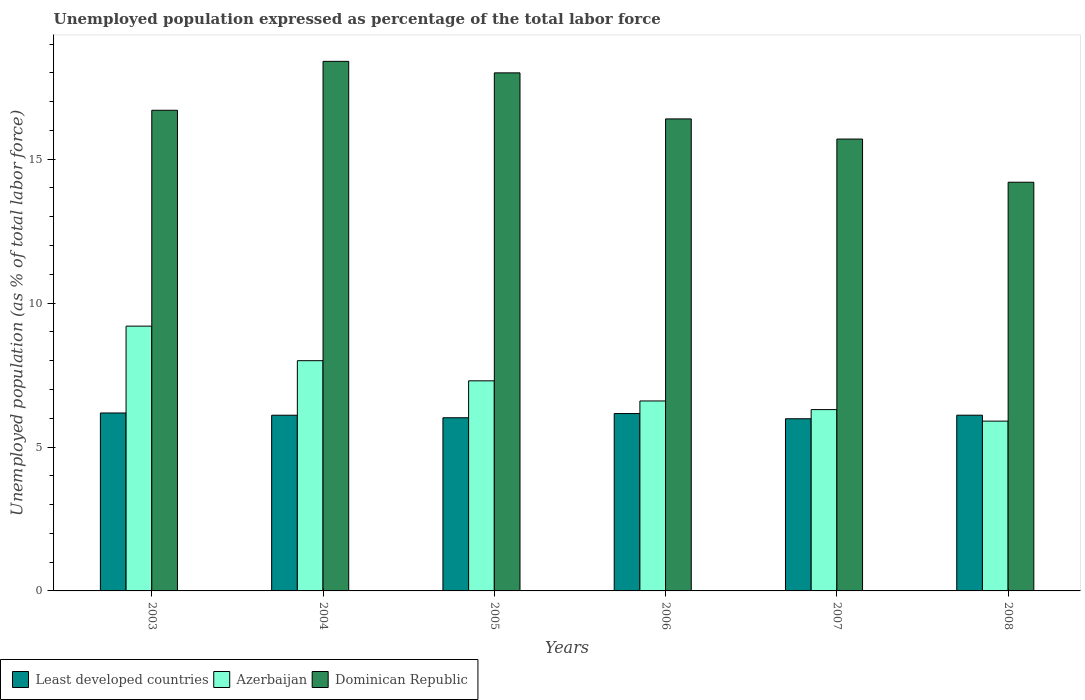How many groups of bars are there?
Your answer should be very brief. 6. Are the number of bars per tick equal to the number of legend labels?
Your answer should be compact. Yes. What is the label of the 1st group of bars from the left?
Your answer should be compact. 2003. In how many cases, is the number of bars for a given year not equal to the number of legend labels?
Offer a terse response. 0. Across all years, what is the maximum unemployment in in Dominican Republic?
Your answer should be very brief. 18.4. Across all years, what is the minimum unemployment in in Least developed countries?
Offer a very short reply. 5.98. In which year was the unemployment in in Azerbaijan minimum?
Your answer should be compact. 2008. What is the total unemployment in in Dominican Republic in the graph?
Ensure brevity in your answer.  99.4. What is the difference between the unemployment in in Azerbaijan in 2003 and that in 2004?
Offer a very short reply. 1.2. What is the difference between the unemployment in in Dominican Republic in 2008 and the unemployment in in Azerbaijan in 2003?
Keep it short and to the point. 5. What is the average unemployment in in Azerbaijan per year?
Keep it short and to the point. 7.22. In the year 2003, what is the difference between the unemployment in in Dominican Republic and unemployment in in Least developed countries?
Keep it short and to the point. 10.52. What is the ratio of the unemployment in in Least developed countries in 2005 to that in 2008?
Provide a short and direct response. 0.99. Is the unemployment in in Azerbaijan in 2007 less than that in 2008?
Offer a terse response. No. What is the difference between the highest and the second highest unemployment in in Least developed countries?
Keep it short and to the point. 0.02. What is the difference between the highest and the lowest unemployment in in Azerbaijan?
Offer a terse response. 3.3. Is the sum of the unemployment in in Least developed countries in 2004 and 2008 greater than the maximum unemployment in in Dominican Republic across all years?
Your answer should be very brief. No. What does the 3rd bar from the left in 2005 represents?
Your answer should be compact. Dominican Republic. What does the 3rd bar from the right in 2005 represents?
Give a very brief answer. Least developed countries. Is it the case that in every year, the sum of the unemployment in in Azerbaijan and unemployment in in Dominican Republic is greater than the unemployment in in Least developed countries?
Make the answer very short. Yes. How many bars are there?
Provide a short and direct response. 18. Are all the bars in the graph horizontal?
Your answer should be compact. No. What is the title of the graph?
Ensure brevity in your answer.  Unemployed population expressed as percentage of the total labor force. What is the label or title of the X-axis?
Give a very brief answer. Years. What is the label or title of the Y-axis?
Offer a very short reply. Unemployed population (as % of total labor force). What is the Unemployed population (as % of total labor force) in Least developed countries in 2003?
Make the answer very short. 6.18. What is the Unemployed population (as % of total labor force) of Azerbaijan in 2003?
Ensure brevity in your answer.  9.2. What is the Unemployed population (as % of total labor force) of Dominican Republic in 2003?
Provide a short and direct response. 16.7. What is the Unemployed population (as % of total labor force) of Least developed countries in 2004?
Provide a succinct answer. 6.1. What is the Unemployed population (as % of total labor force) of Dominican Republic in 2004?
Make the answer very short. 18.4. What is the Unemployed population (as % of total labor force) in Least developed countries in 2005?
Give a very brief answer. 6.02. What is the Unemployed population (as % of total labor force) of Azerbaijan in 2005?
Your response must be concise. 7.3. What is the Unemployed population (as % of total labor force) in Least developed countries in 2006?
Provide a succinct answer. 6.16. What is the Unemployed population (as % of total labor force) of Azerbaijan in 2006?
Provide a short and direct response. 6.6. What is the Unemployed population (as % of total labor force) of Dominican Republic in 2006?
Make the answer very short. 16.4. What is the Unemployed population (as % of total labor force) of Least developed countries in 2007?
Give a very brief answer. 5.98. What is the Unemployed population (as % of total labor force) of Azerbaijan in 2007?
Keep it short and to the point. 6.3. What is the Unemployed population (as % of total labor force) of Dominican Republic in 2007?
Your answer should be very brief. 15.7. What is the Unemployed population (as % of total labor force) in Least developed countries in 2008?
Your answer should be compact. 6.11. What is the Unemployed population (as % of total labor force) of Azerbaijan in 2008?
Your answer should be compact. 5.9. What is the Unemployed population (as % of total labor force) in Dominican Republic in 2008?
Make the answer very short. 14.2. Across all years, what is the maximum Unemployed population (as % of total labor force) in Least developed countries?
Offer a very short reply. 6.18. Across all years, what is the maximum Unemployed population (as % of total labor force) in Azerbaijan?
Provide a short and direct response. 9.2. Across all years, what is the maximum Unemployed population (as % of total labor force) of Dominican Republic?
Your response must be concise. 18.4. Across all years, what is the minimum Unemployed population (as % of total labor force) in Least developed countries?
Offer a terse response. 5.98. Across all years, what is the minimum Unemployed population (as % of total labor force) of Azerbaijan?
Give a very brief answer. 5.9. Across all years, what is the minimum Unemployed population (as % of total labor force) of Dominican Republic?
Keep it short and to the point. 14.2. What is the total Unemployed population (as % of total labor force) of Least developed countries in the graph?
Your response must be concise. 36.55. What is the total Unemployed population (as % of total labor force) in Azerbaijan in the graph?
Give a very brief answer. 43.3. What is the total Unemployed population (as % of total labor force) of Dominican Republic in the graph?
Keep it short and to the point. 99.4. What is the difference between the Unemployed population (as % of total labor force) of Least developed countries in 2003 and that in 2004?
Provide a short and direct response. 0.08. What is the difference between the Unemployed population (as % of total labor force) of Dominican Republic in 2003 and that in 2004?
Your answer should be compact. -1.7. What is the difference between the Unemployed population (as % of total labor force) in Least developed countries in 2003 and that in 2005?
Ensure brevity in your answer.  0.17. What is the difference between the Unemployed population (as % of total labor force) of Dominican Republic in 2003 and that in 2005?
Your response must be concise. -1.3. What is the difference between the Unemployed population (as % of total labor force) of Least developed countries in 2003 and that in 2006?
Provide a succinct answer. 0.02. What is the difference between the Unemployed population (as % of total labor force) in Least developed countries in 2003 and that in 2007?
Offer a terse response. 0.2. What is the difference between the Unemployed population (as % of total labor force) in Least developed countries in 2003 and that in 2008?
Provide a succinct answer. 0.08. What is the difference between the Unemployed population (as % of total labor force) of Dominican Republic in 2003 and that in 2008?
Your answer should be compact. 2.5. What is the difference between the Unemployed population (as % of total labor force) in Least developed countries in 2004 and that in 2005?
Your answer should be very brief. 0.09. What is the difference between the Unemployed population (as % of total labor force) in Azerbaijan in 2004 and that in 2005?
Your response must be concise. 0.7. What is the difference between the Unemployed population (as % of total labor force) of Least developed countries in 2004 and that in 2006?
Provide a short and direct response. -0.06. What is the difference between the Unemployed population (as % of total labor force) in Azerbaijan in 2004 and that in 2006?
Provide a succinct answer. 1.4. What is the difference between the Unemployed population (as % of total labor force) of Dominican Republic in 2004 and that in 2006?
Your answer should be compact. 2. What is the difference between the Unemployed population (as % of total labor force) of Least developed countries in 2004 and that in 2007?
Your answer should be compact. 0.12. What is the difference between the Unemployed population (as % of total labor force) of Azerbaijan in 2004 and that in 2007?
Offer a terse response. 1.7. What is the difference between the Unemployed population (as % of total labor force) of Dominican Republic in 2004 and that in 2007?
Ensure brevity in your answer.  2.7. What is the difference between the Unemployed population (as % of total labor force) in Least developed countries in 2004 and that in 2008?
Provide a short and direct response. -0. What is the difference between the Unemployed population (as % of total labor force) in Least developed countries in 2005 and that in 2006?
Make the answer very short. -0.15. What is the difference between the Unemployed population (as % of total labor force) of Dominican Republic in 2005 and that in 2006?
Your answer should be compact. 1.6. What is the difference between the Unemployed population (as % of total labor force) of Least developed countries in 2005 and that in 2007?
Your answer should be compact. 0.03. What is the difference between the Unemployed population (as % of total labor force) in Dominican Republic in 2005 and that in 2007?
Offer a terse response. 2.3. What is the difference between the Unemployed population (as % of total labor force) in Least developed countries in 2005 and that in 2008?
Offer a very short reply. -0.09. What is the difference between the Unemployed population (as % of total labor force) of Azerbaijan in 2005 and that in 2008?
Ensure brevity in your answer.  1.4. What is the difference between the Unemployed population (as % of total labor force) in Dominican Republic in 2005 and that in 2008?
Offer a very short reply. 3.8. What is the difference between the Unemployed population (as % of total labor force) of Least developed countries in 2006 and that in 2007?
Offer a very short reply. 0.18. What is the difference between the Unemployed population (as % of total labor force) in Azerbaijan in 2006 and that in 2007?
Ensure brevity in your answer.  0.3. What is the difference between the Unemployed population (as % of total labor force) in Least developed countries in 2006 and that in 2008?
Provide a succinct answer. 0.06. What is the difference between the Unemployed population (as % of total labor force) of Azerbaijan in 2006 and that in 2008?
Offer a terse response. 0.7. What is the difference between the Unemployed population (as % of total labor force) of Least developed countries in 2007 and that in 2008?
Provide a short and direct response. -0.12. What is the difference between the Unemployed population (as % of total labor force) of Least developed countries in 2003 and the Unemployed population (as % of total labor force) of Azerbaijan in 2004?
Make the answer very short. -1.82. What is the difference between the Unemployed population (as % of total labor force) of Least developed countries in 2003 and the Unemployed population (as % of total labor force) of Dominican Republic in 2004?
Provide a short and direct response. -12.22. What is the difference between the Unemployed population (as % of total labor force) of Azerbaijan in 2003 and the Unemployed population (as % of total labor force) of Dominican Republic in 2004?
Offer a terse response. -9.2. What is the difference between the Unemployed population (as % of total labor force) of Least developed countries in 2003 and the Unemployed population (as % of total labor force) of Azerbaijan in 2005?
Keep it short and to the point. -1.12. What is the difference between the Unemployed population (as % of total labor force) of Least developed countries in 2003 and the Unemployed population (as % of total labor force) of Dominican Republic in 2005?
Offer a very short reply. -11.82. What is the difference between the Unemployed population (as % of total labor force) of Least developed countries in 2003 and the Unemployed population (as % of total labor force) of Azerbaijan in 2006?
Your answer should be very brief. -0.42. What is the difference between the Unemployed population (as % of total labor force) in Least developed countries in 2003 and the Unemployed population (as % of total labor force) in Dominican Republic in 2006?
Your answer should be very brief. -10.22. What is the difference between the Unemployed population (as % of total labor force) of Azerbaijan in 2003 and the Unemployed population (as % of total labor force) of Dominican Republic in 2006?
Give a very brief answer. -7.2. What is the difference between the Unemployed population (as % of total labor force) of Least developed countries in 2003 and the Unemployed population (as % of total labor force) of Azerbaijan in 2007?
Keep it short and to the point. -0.12. What is the difference between the Unemployed population (as % of total labor force) in Least developed countries in 2003 and the Unemployed population (as % of total labor force) in Dominican Republic in 2007?
Your answer should be compact. -9.52. What is the difference between the Unemployed population (as % of total labor force) in Azerbaijan in 2003 and the Unemployed population (as % of total labor force) in Dominican Republic in 2007?
Keep it short and to the point. -6.5. What is the difference between the Unemployed population (as % of total labor force) in Least developed countries in 2003 and the Unemployed population (as % of total labor force) in Azerbaijan in 2008?
Ensure brevity in your answer.  0.28. What is the difference between the Unemployed population (as % of total labor force) of Least developed countries in 2003 and the Unemployed population (as % of total labor force) of Dominican Republic in 2008?
Keep it short and to the point. -8.02. What is the difference between the Unemployed population (as % of total labor force) in Azerbaijan in 2003 and the Unemployed population (as % of total labor force) in Dominican Republic in 2008?
Keep it short and to the point. -5. What is the difference between the Unemployed population (as % of total labor force) in Least developed countries in 2004 and the Unemployed population (as % of total labor force) in Azerbaijan in 2005?
Your answer should be compact. -1.2. What is the difference between the Unemployed population (as % of total labor force) in Least developed countries in 2004 and the Unemployed population (as % of total labor force) in Dominican Republic in 2005?
Give a very brief answer. -11.9. What is the difference between the Unemployed population (as % of total labor force) of Least developed countries in 2004 and the Unemployed population (as % of total labor force) of Azerbaijan in 2006?
Provide a short and direct response. -0.5. What is the difference between the Unemployed population (as % of total labor force) in Least developed countries in 2004 and the Unemployed population (as % of total labor force) in Dominican Republic in 2006?
Your answer should be compact. -10.3. What is the difference between the Unemployed population (as % of total labor force) of Azerbaijan in 2004 and the Unemployed population (as % of total labor force) of Dominican Republic in 2006?
Your response must be concise. -8.4. What is the difference between the Unemployed population (as % of total labor force) of Least developed countries in 2004 and the Unemployed population (as % of total labor force) of Azerbaijan in 2007?
Your response must be concise. -0.2. What is the difference between the Unemployed population (as % of total labor force) in Least developed countries in 2004 and the Unemployed population (as % of total labor force) in Dominican Republic in 2007?
Ensure brevity in your answer.  -9.6. What is the difference between the Unemployed population (as % of total labor force) of Azerbaijan in 2004 and the Unemployed population (as % of total labor force) of Dominican Republic in 2007?
Ensure brevity in your answer.  -7.7. What is the difference between the Unemployed population (as % of total labor force) in Least developed countries in 2004 and the Unemployed population (as % of total labor force) in Azerbaijan in 2008?
Your answer should be very brief. 0.2. What is the difference between the Unemployed population (as % of total labor force) in Least developed countries in 2004 and the Unemployed population (as % of total labor force) in Dominican Republic in 2008?
Provide a short and direct response. -8.1. What is the difference between the Unemployed population (as % of total labor force) in Least developed countries in 2005 and the Unemployed population (as % of total labor force) in Azerbaijan in 2006?
Ensure brevity in your answer.  -0.58. What is the difference between the Unemployed population (as % of total labor force) in Least developed countries in 2005 and the Unemployed population (as % of total labor force) in Dominican Republic in 2006?
Provide a succinct answer. -10.38. What is the difference between the Unemployed population (as % of total labor force) in Least developed countries in 2005 and the Unemployed population (as % of total labor force) in Azerbaijan in 2007?
Keep it short and to the point. -0.28. What is the difference between the Unemployed population (as % of total labor force) in Least developed countries in 2005 and the Unemployed population (as % of total labor force) in Dominican Republic in 2007?
Provide a short and direct response. -9.68. What is the difference between the Unemployed population (as % of total labor force) in Azerbaijan in 2005 and the Unemployed population (as % of total labor force) in Dominican Republic in 2007?
Keep it short and to the point. -8.4. What is the difference between the Unemployed population (as % of total labor force) of Least developed countries in 2005 and the Unemployed population (as % of total labor force) of Azerbaijan in 2008?
Give a very brief answer. 0.12. What is the difference between the Unemployed population (as % of total labor force) in Least developed countries in 2005 and the Unemployed population (as % of total labor force) in Dominican Republic in 2008?
Keep it short and to the point. -8.18. What is the difference between the Unemployed population (as % of total labor force) of Least developed countries in 2006 and the Unemployed population (as % of total labor force) of Azerbaijan in 2007?
Provide a short and direct response. -0.14. What is the difference between the Unemployed population (as % of total labor force) in Least developed countries in 2006 and the Unemployed population (as % of total labor force) in Dominican Republic in 2007?
Provide a short and direct response. -9.54. What is the difference between the Unemployed population (as % of total labor force) of Least developed countries in 2006 and the Unemployed population (as % of total labor force) of Azerbaijan in 2008?
Make the answer very short. 0.26. What is the difference between the Unemployed population (as % of total labor force) of Least developed countries in 2006 and the Unemployed population (as % of total labor force) of Dominican Republic in 2008?
Your response must be concise. -8.04. What is the difference between the Unemployed population (as % of total labor force) of Least developed countries in 2007 and the Unemployed population (as % of total labor force) of Azerbaijan in 2008?
Provide a short and direct response. 0.08. What is the difference between the Unemployed population (as % of total labor force) in Least developed countries in 2007 and the Unemployed population (as % of total labor force) in Dominican Republic in 2008?
Make the answer very short. -8.22. What is the difference between the Unemployed population (as % of total labor force) of Azerbaijan in 2007 and the Unemployed population (as % of total labor force) of Dominican Republic in 2008?
Your answer should be compact. -7.9. What is the average Unemployed population (as % of total labor force) in Least developed countries per year?
Your answer should be compact. 6.09. What is the average Unemployed population (as % of total labor force) in Azerbaijan per year?
Provide a short and direct response. 7.22. What is the average Unemployed population (as % of total labor force) of Dominican Republic per year?
Provide a succinct answer. 16.57. In the year 2003, what is the difference between the Unemployed population (as % of total labor force) of Least developed countries and Unemployed population (as % of total labor force) of Azerbaijan?
Offer a very short reply. -3.02. In the year 2003, what is the difference between the Unemployed population (as % of total labor force) of Least developed countries and Unemployed population (as % of total labor force) of Dominican Republic?
Your answer should be very brief. -10.52. In the year 2004, what is the difference between the Unemployed population (as % of total labor force) in Least developed countries and Unemployed population (as % of total labor force) in Azerbaijan?
Your response must be concise. -1.9. In the year 2004, what is the difference between the Unemployed population (as % of total labor force) in Least developed countries and Unemployed population (as % of total labor force) in Dominican Republic?
Offer a terse response. -12.3. In the year 2005, what is the difference between the Unemployed population (as % of total labor force) of Least developed countries and Unemployed population (as % of total labor force) of Azerbaijan?
Offer a very short reply. -1.28. In the year 2005, what is the difference between the Unemployed population (as % of total labor force) of Least developed countries and Unemployed population (as % of total labor force) of Dominican Republic?
Keep it short and to the point. -11.98. In the year 2005, what is the difference between the Unemployed population (as % of total labor force) in Azerbaijan and Unemployed population (as % of total labor force) in Dominican Republic?
Make the answer very short. -10.7. In the year 2006, what is the difference between the Unemployed population (as % of total labor force) of Least developed countries and Unemployed population (as % of total labor force) of Azerbaijan?
Your response must be concise. -0.44. In the year 2006, what is the difference between the Unemployed population (as % of total labor force) of Least developed countries and Unemployed population (as % of total labor force) of Dominican Republic?
Keep it short and to the point. -10.24. In the year 2007, what is the difference between the Unemployed population (as % of total labor force) in Least developed countries and Unemployed population (as % of total labor force) in Azerbaijan?
Make the answer very short. -0.32. In the year 2007, what is the difference between the Unemployed population (as % of total labor force) of Least developed countries and Unemployed population (as % of total labor force) of Dominican Republic?
Your response must be concise. -9.72. In the year 2008, what is the difference between the Unemployed population (as % of total labor force) of Least developed countries and Unemployed population (as % of total labor force) of Azerbaijan?
Your response must be concise. 0.21. In the year 2008, what is the difference between the Unemployed population (as % of total labor force) of Least developed countries and Unemployed population (as % of total labor force) of Dominican Republic?
Provide a succinct answer. -8.09. In the year 2008, what is the difference between the Unemployed population (as % of total labor force) in Azerbaijan and Unemployed population (as % of total labor force) in Dominican Republic?
Your answer should be very brief. -8.3. What is the ratio of the Unemployed population (as % of total labor force) of Least developed countries in 2003 to that in 2004?
Make the answer very short. 1.01. What is the ratio of the Unemployed population (as % of total labor force) of Azerbaijan in 2003 to that in 2004?
Provide a short and direct response. 1.15. What is the ratio of the Unemployed population (as % of total labor force) in Dominican Republic in 2003 to that in 2004?
Give a very brief answer. 0.91. What is the ratio of the Unemployed population (as % of total labor force) of Least developed countries in 2003 to that in 2005?
Make the answer very short. 1.03. What is the ratio of the Unemployed population (as % of total labor force) of Azerbaijan in 2003 to that in 2005?
Provide a succinct answer. 1.26. What is the ratio of the Unemployed population (as % of total labor force) of Dominican Republic in 2003 to that in 2005?
Provide a succinct answer. 0.93. What is the ratio of the Unemployed population (as % of total labor force) in Least developed countries in 2003 to that in 2006?
Offer a terse response. 1. What is the ratio of the Unemployed population (as % of total labor force) in Azerbaijan in 2003 to that in 2006?
Your answer should be very brief. 1.39. What is the ratio of the Unemployed population (as % of total labor force) of Dominican Republic in 2003 to that in 2006?
Offer a very short reply. 1.02. What is the ratio of the Unemployed population (as % of total labor force) of Least developed countries in 2003 to that in 2007?
Offer a very short reply. 1.03. What is the ratio of the Unemployed population (as % of total labor force) of Azerbaijan in 2003 to that in 2007?
Provide a short and direct response. 1.46. What is the ratio of the Unemployed population (as % of total labor force) in Dominican Republic in 2003 to that in 2007?
Ensure brevity in your answer.  1.06. What is the ratio of the Unemployed population (as % of total labor force) of Least developed countries in 2003 to that in 2008?
Your answer should be very brief. 1.01. What is the ratio of the Unemployed population (as % of total labor force) of Azerbaijan in 2003 to that in 2008?
Your answer should be compact. 1.56. What is the ratio of the Unemployed population (as % of total labor force) in Dominican Republic in 2003 to that in 2008?
Offer a very short reply. 1.18. What is the ratio of the Unemployed population (as % of total labor force) of Least developed countries in 2004 to that in 2005?
Ensure brevity in your answer.  1.01. What is the ratio of the Unemployed population (as % of total labor force) of Azerbaijan in 2004 to that in 2005?
Ensure brevity in your answer.  1.1. What is the ratio of the Unemployed population (as % of total labor force) in Dominican Republic in 2004 to that in 2005?
Your answer should be compact. 1.02. What is the ratio of the Unemployed population (as % of total labor force) of Least developed countries in 2004 to that in 2006?
Your answer should be very brief. 0.99. What is the ratio of the Unemployed population (as % of total labor force) in Azerbaijan in 2004 to that in 2006?
Ensure brevity in your answer.  1.21. What is the ratio of the Unemployed population (as % of total labor force) in Dominican Republic in 2004 to that in 2006?
Give a very brief answer. 1.12. What is the ratio of the Unemployed population (as % of total labor force) of Least developed countries in 2004 to that in 2007?
Offer a terse response. 1.02. What is the ratio of the Unemployed population (as % of total labor force) of Azerbaijan in 2004 to that in 2007?
Offer a terse response. 1.27. What is the ratio of the Unemployed population (as % of total labor force) of Dominican Republic in 2004 to that in 2007?
Give a very brief answer. 1.17. What is the ratio of the Unemployed population (as % of total labor force) in Least developed countries in 2004 to that in 2008?
Your answer should be compact. 1. What is the ratio of the Unemployed population (as % of total labor force) in Azerbaijan in 2004 to that in 2008?
Your answer should be compact. 1.36. What is the ratio of the Unemployed population (as % of total labor force) of Dominican Republic in 2004 to that in 2008?
Provide a short and direct response. 1.3. What is the ratio of the Unemployed population (as % of total labor force) of Least developed countries in 2005 to that in 2006?
Ensure brevity in your answer.  0.98. What is the ratio of the Unemployed population (as % of total labor force) of Azerbaijan in 2005 to that in 2006?
Provide a short and direct response. 1.11. What is the ratio of the Unemployed population (as % of total labor force) in Dominican Republic in 2005 to that in 2006?
Provide a short and direct response. 1.1. What is the ratio of the Unemployed population (as % of total labor force) in Azerbaijan in 2005 to that in 2007?
Ensure brevity in your answer.  1.16. What is the ratio of the Unemployed population (as % of total labor force) of Dominican Republic in 2005 to that in 2007?
Provide a short and direct response. 1.15. What is the ratio of the Unemployed population (as % of total labor force) of Least developed countries in 2005 to that in 2008?
Make the answer very short. 0.99. What is the ratio of the Unemployed population (as % of total labor force) of Azerbaijan in 2005 to that in 2008?
Your answer should be very brief. 1.24. What is the ratio of the Unemployed population (as % of total labor force) of Dominican Republic in 2005 to that in 2008?
Provide a short and direct response. 1.27. What is the ratio of the Unemployed population (as % of total labor force) in Least developed countries in 2006 to that in 2007?
Offer a terse response. 1.03. What is the ratio of the Unemployed population (as % of total labor force) in Azerbaijan in 2006 to that in 2007?
Offer a very short reply. 1.05. What is the ratio of the Unemployed population (as % of total labor force) in Dominican Republic in 2006 to that in 2007?
Offer a very short reply. 1.04. What is the ratio of the Unemployed population (as % of total labor force) of Least developed countries in 2006 to that in 2008?
Offer a terse response. 1.01. What is the ratio of the Unemployed population (as % of total labor force) of Azerbaijan in 2006 to that in 2008?
Your answer should be very brief. 1.12. What is the ratio of the Unemployed population (as % of total labor force) in Dominican Republic in 2006 to that in 2008?
Offer a terse response. 1.15. What is the ratio of the Unemployed population (as % of total labor force) of Least developed countries in 2007 to that in 2008?
Offer a terse response. 0.98. What is the ratio of the Unemployed population (as % of total labor force) of Azerbaijan in 2007 to that in 2008?
Provide a short and direct response. 1.07. What is the ratio of the Unemployed population (as % of total labor force) of Dominican Republic in 2007 to that in 2008?
Give a very brief answer. 1.11. What is the difference between the highest and the second highest Unemployed population (as % of total labor force) in Least developed countries?
Your answer should be very brief. 0.02. What is the difference between the highest and the second highest Unemployed population (as % of total labor force) in Azerbaijan?
Provide a succinct answer. 1.2. What is the difference between the highest and the lowest Unemployed population (as % of total labor force) of Least developed countries?
Your response must be concise. 0.2. 